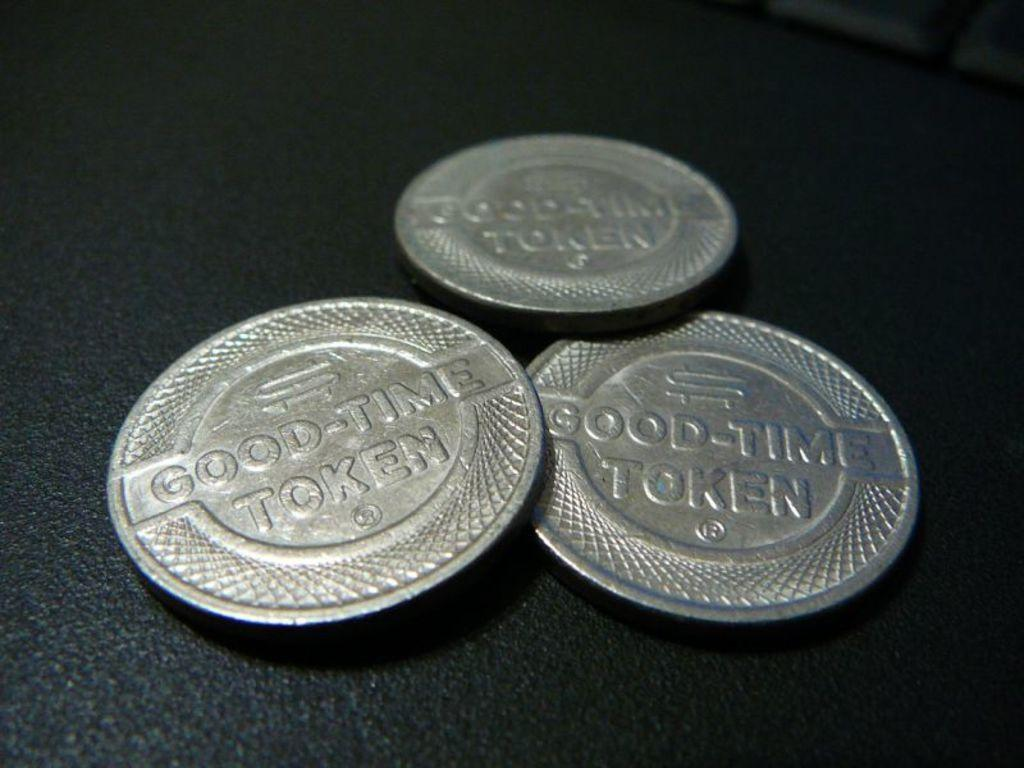<image>
Create a compact narrative representing the image presented. Three Good Time Tokens on a black surface 